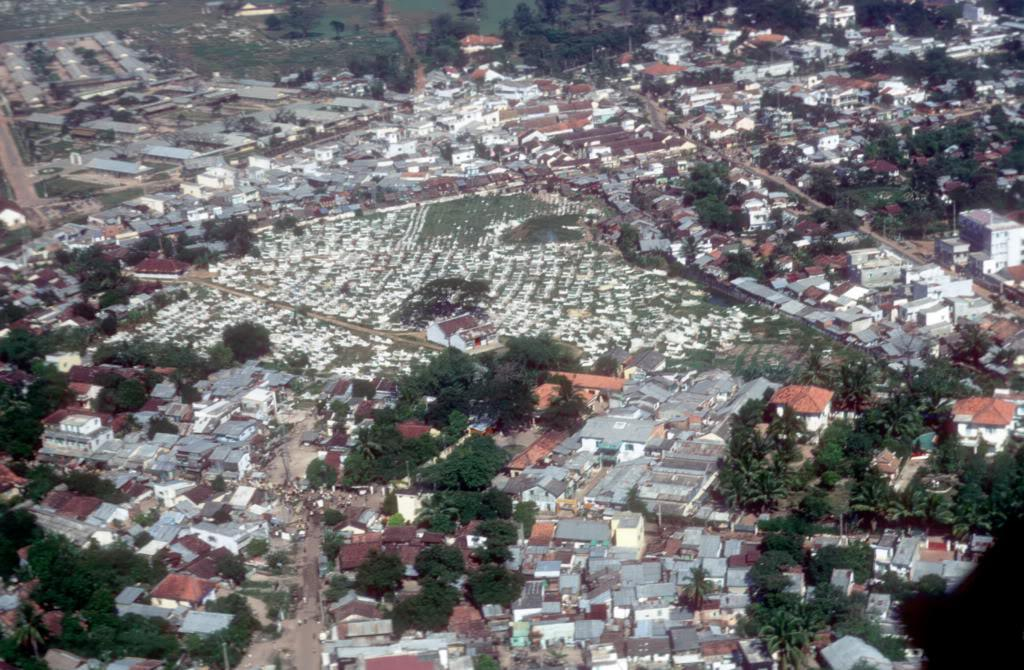What type of view is depicted in the image? The image is an aerial view. What structures can be seen in the image? There are buildings in the image. What type of vegetation is visible in the image? There are trees in the image. What type of ground cover is visible in the image? There is grass visible in the image. Can you see a pig in the yard in the image? There is no pig or yard present in the image. What type of material is the pig rubbing against in the image? There is no pig or rubbing material present in the image. 